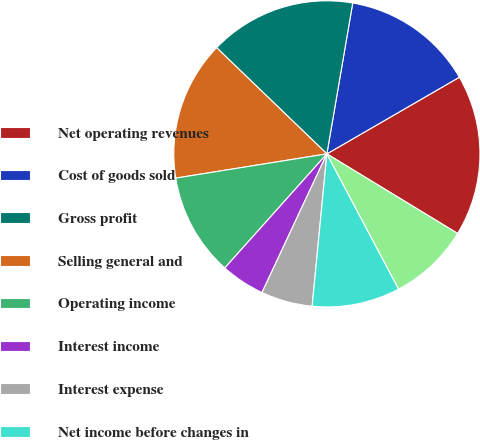Convert chart to OTSL. <chart><loc_0><loc_0><loc_500><loc_500><pie_chart><fcel>Net operating revenues<fcel>Cost of goods sold<fcel>Gross profit<fcel>Selling general and<fcel>Operating income<fcel>Interest income<fcel>Interest expense<fcel>Net income before changes in<fcel>Average shares outstanding<nl><fcel>17.05%<fcel>13.95%<fcel>15.5%<fcel>14.73%<fcel>10.85%<fcel>4.65%<fcel>5.43%<fcel>9.3%<fcel>8.53%<nl></chart> 